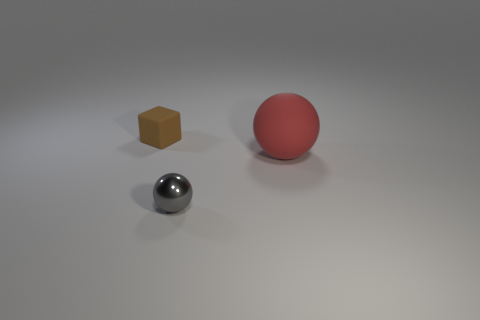Add 2 green matte objects. How many objects exist? 5 Subtract all cubes. How many objects are left? 2 Subtract 0 brown cylinders. How many objects are left? 3 Subtract all small gray things. Subtract all balls. How many objects are left? 0 Add 2 gray shiny spheres. How many gray shiny spheres are left? 3 Add 1 purple cylinders. How many purple cylinders exist? 1 